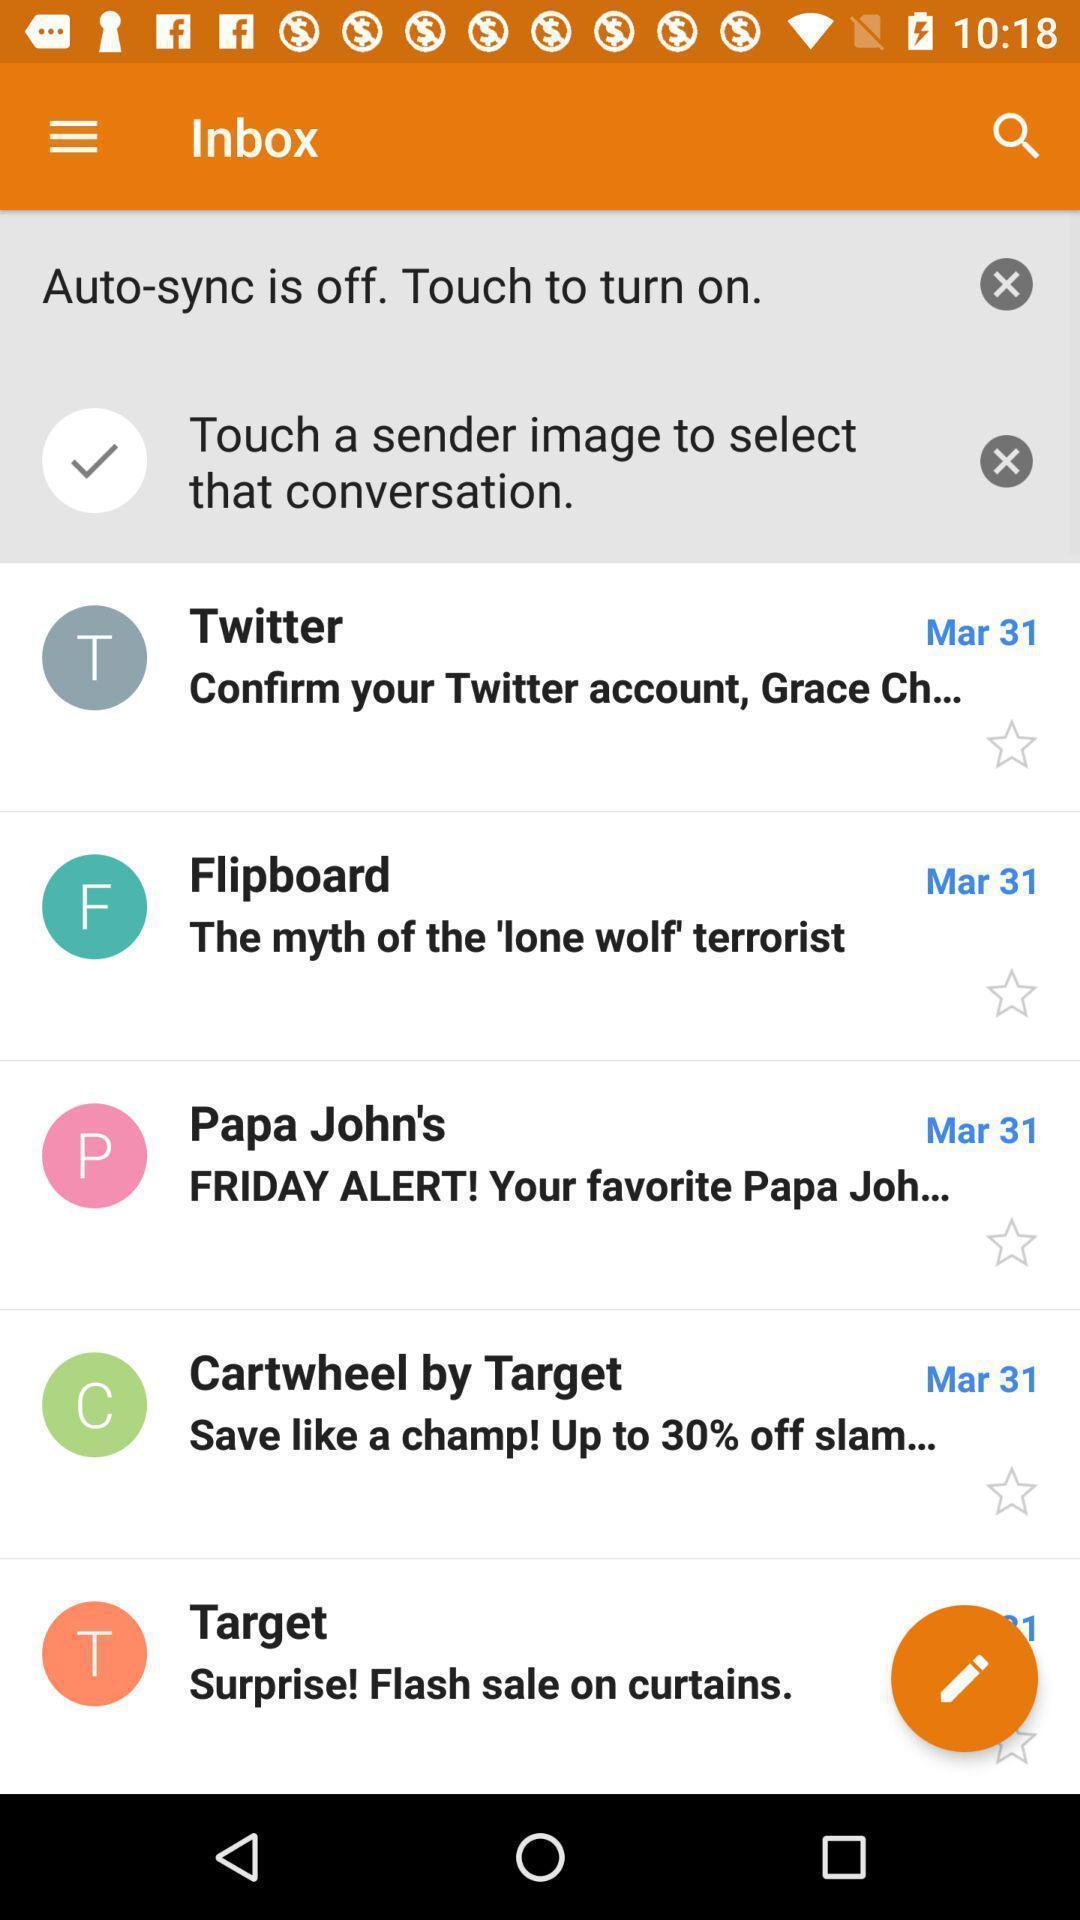Tell me what you see in this picture. Screen shows inbox of mails in social app. 